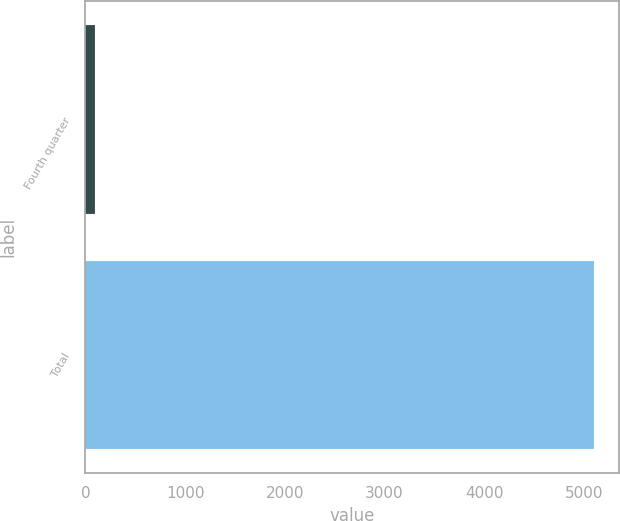Convert chart to OTSL. <chart><loc_0><loc_0><loc_500><loc_500><bar_chart><fcel>Fourth quarter<fcel>Total<nl><fcel>100<fcel>5100<nl></chart> 